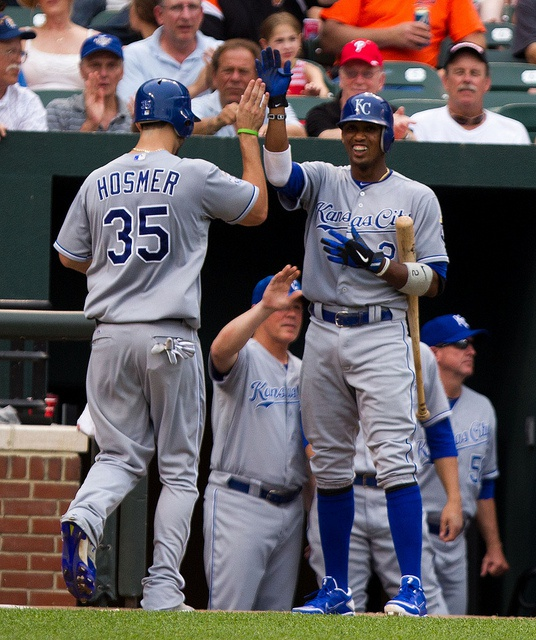Describe the objects in this image and their specific colors. I can see people in black, darkgray, gray, and lavender tones, people in black, darkgray, gray, and navy tones, people in black, darkgray, and gray tones, people in black, brown, lavender, and red tones, and people in black, darkgray, and gray tones in this image. 